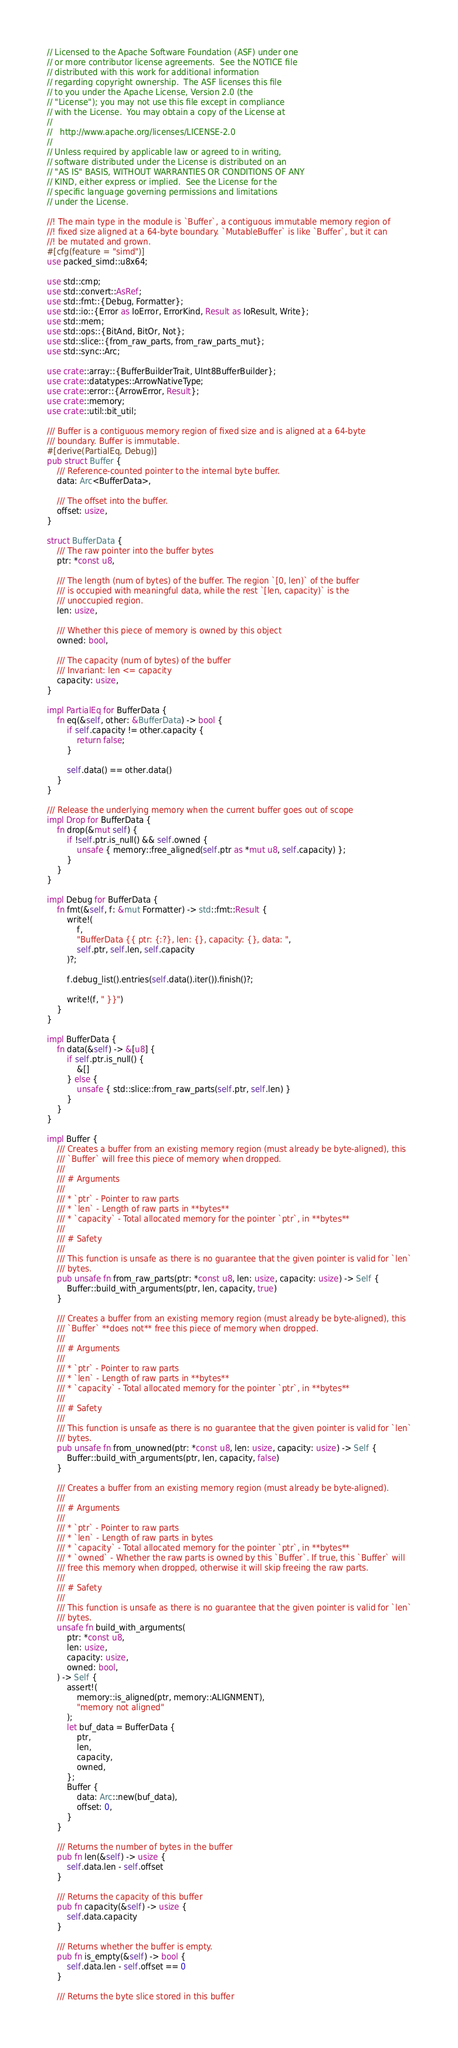Convert code to text. <code><loc_0><loc_0><loc_500><loc_500><_Rust_>// Licensed to the Apache Software Foundation (ASF) under one
// or more contributor license agreements.  See the NOTICE file
// distributed with this work for additional information
// regarding copyright ownership.  The ASF licenses this file
// to you under the Apache License, Version 2.0 (the
// "License"); you may not use this file except in compliance
// with the License.  You may obtain a copy of the License at
//
//   http://www.apache.org/licenses/LICENSE-2.0
//
// Unless required by applicable law or agreed to in writing,
// software distributed under the License is distributed on an
// "AS IS" BASIS, WITHOUT WARRANTIES OR CONDITIONS OF ANY
// KIND, either express or implied.  See the License for the
// specific language governing permissions and limitations
// under the License.

//! The main type in the module is `Buffer`, a contiguous immutable memory region of
//! fixed size aligned at a 64-byte boundary. `MutableBuffer` is like `Buffer`, but it can
//! be mutated and grown.
#[cfg(feature = "simd")]
use packed_simd::u8x64;

use std::cmp;
use std::convert::AsRef;
use std::fmt::{Debug, Formatter};
use std::io::{Error as IoError, ErrorKind, Result as IoResult, Write};
use std::mem;
use std::ops::{BitAnd, BitOr, Not};
use std::slice::{from_raw_parts, from_raw_parts_mut};
use std::sync::Arc;

use crate::array::{BufferBuilderTrait, UInt8BufferBuilder};
use crate::datatypes::ArrowNativeType;
use crate::error::{ArrowError, Result};
use crate::memory;
use crate::util::bit_util;

/// Buffer is a contiguous memory region of fixed size and is aligned at a 64-byte
/// boundary. Buffer is immutable.
#[derive(PartialEq, Debug)]
pub struct Buffer {
    /// Reference-counted pointer to the internal byte buffer.
    data: Arc<BufferData>,

    /// The offset into the buffer.
    offset: usize,
}

struct BufferData {
    /// The raw pointer into the buffer bytes
    ptr: *const u8,

    /// The length (num of bytes) of the buffer. The region `[0, len)` of the buffer
    /// is occupied with meaningful data, while the rest `[len, capacity)` is the
    /// unoccupied region.
    len: usize,

    /// Whether this piece of memory is owned by this object
    owned: bool,

    /// The capacity (num of bytes) of the buffer
    /// Invariant: len <= capacity
    capacity: usize,
}

impl PartialEq for BufferData {
    fn eq(&self, other: &BufferData) -> bool {
        if self.capacity != other.capacity {
            return false;
        }

        self.data() == other.data()
    }
}

/// Release the underlying memory when the current buffer goes out of scope
impl Drop for BufferData {
    fn drop(&mut self) {
        if !self.ptr.is_null() && self.owned {
            unsafe { memory::free_aligned(self.ptr as *mut u8, self.capacity) };
        }
    }
}

impl Debug for BufferData {
    fn fmt(&self, f: &mut Formatter) -> std::fmt::Result {
        write!(
            f,
            "BufferData {{ ptr: {:?}, len: {}, capacity: {}, data: ",
            self.ptr, self.len, self.capacity
        )?;

        f.debug_list().entries(self.data().iter()).finish()?;

        write!(f, " }}")
    }
}

impl BufferData {
    fn data(&self) -> &[u8] {
        if self.ptr.is_null() {
            &[]
        } else {
            unsafe { std::slice::from_raw_parts(self.ptr, self.len) }
        }
    }
}

impl Buffer {
    /// Creates a buffer from an existing memory region (must already be byte-aligned), this
    /// `Buffer` will free this piece of memory when dropped.
    ///
    /// # Arguments
    ///
    /// * `ptr` - Pointer to raw parts
    /// * `len` - Length of raw parts in **bytes**
    /// * `capacity` - Total allocated memory for the pointer `ptr`, in **bytes**
    ///
    /// # Safety
    ///
    /// This function is unsafe as there is no guarantee that the given pointer is valid for `len`
    /// bytes.
    pub unsafe fn from_raw_parts(ptr: *const u8, len: usize, capacity: usize) -> Self {
        Buffer::build_with_arguments(ptr, len, capacity, true)
    }

    /// Creates a buffer from an existing memory region (must already be byte-aligned), this
    /// `Buffer` **does not** free this piece of memory when dropped.
    ///
    /// # Arguments
    ///
    /// * `ptr` - Pointer to raw parts
    /// * `len` - Length of raw parts in **bytes**
    /// * `capacity` - Total allocated memory for the pointer `ptr`, in **bytes**
    ///
    /// # Safety
    ///
    /// This function is unsafe as there is no guarantee that the given pointer is valid for `len`
    /// bytes.
    pub unsafe fn from_unowned(ptr: *const u8, len: usize, capacity: usize) -> Self {
        Buffer::build_with_arguments(ptr, len, capacity, false)
    }

    /// Creates a buffer from an existing memory region (must already be byte-aligned).
    ///
    /// # Arguments
    ///
    /// * `ptr` - Pointer to raw parts
    /// * `len` - Length of raw parts in bytes
    /// * `capacity` - Total allocated memory for the pointer `ptr`, in **bytes**
    /// * `owned` - Whether the raw parts is owned by this `Buffer`. If true, this `Buffer` will
    /// free this memory when dropped, otherwise it will skip freeing the raw parts.
    ///
    /// # Safety
    ///
    /// This function is unsafe as there is no guarantee that the given pointer is valid for `len`
    /// bytes.
    unsafe fn build_with_arguments(
        ptr: *const u8,
        len: usize,
        capacity: usize,
        owned: bool,
    ) -> Self {
        assert!(
            memory::is_aligned(ptr, memory::ALIGNMENT),
            "memory not aligned"
        );
        let buf_data = BufferData {
            ptr,
            len,
            capacity,
            owned,
        };
        Buffer {
            data: Arc::new(buf_data),
            offset: 0,
        }
    }

    /// Returns the number of bytes in the buffer
    pub fn len(&self) -> usize {
        self.data.len - self.offset
    }

    /// Returns the capacity of this buffer
    pub fn capacity(&self) -> usize {
        self.data.capacity
    }

    /// Returns whether the buffer is empty.
    pub fn is_empty(&self) -> bool {
        self.data.len - self.offset == 0
    }

    /// Returns the byte slice stored in this buffer</code> 